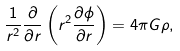Convert formula to latex. <formula><loc_0><loc_0><loc_500><loc_500>\frac { 1 } { r ^ { 2 } } \frac { \partial } { \partial r } \left ( r ^ { 2 } \frac { \partial \phi } { \partial r } \right ) = 4 \pi G \rho ,</formula> 